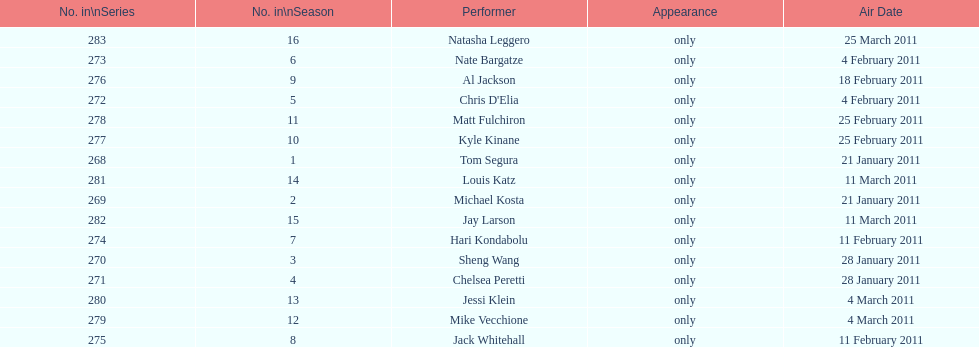How many episodes only had one performer? 16. 